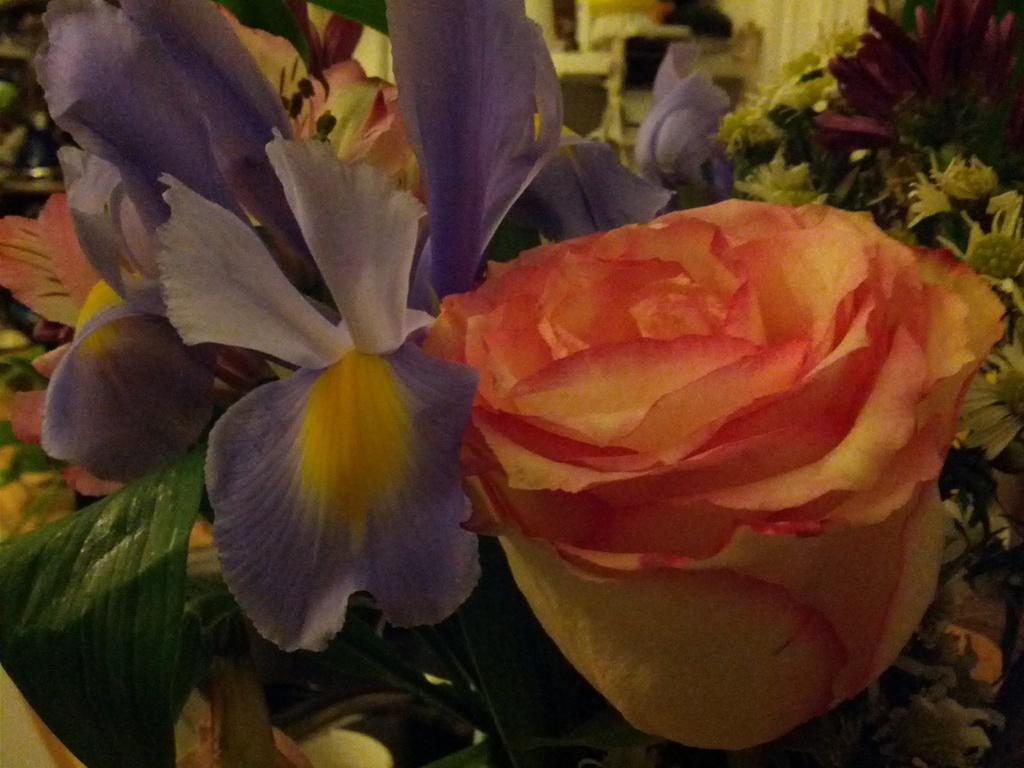What type of living organisms can be seen in the image? There are flowers in the image. What is visible in the background of the image? There is a wall and objects visible in the background of the image. What type of scissors can be seen cutting the flowers in the image? There are no scissors present in the image, and the flowers are not being cut. Who is the creator of the flowers in the image? The flowers are natural living organisms and do not have a specific creator. 